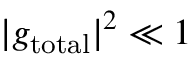Convert formula to latex. <formula><loc_0><loc_0><loc_500><loc_500>| g _ { t o t a l } | ^ { 2 } \ll 1</formula> 